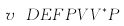<formula> <loc_0><loc_0><loc_500><loc_500>v \ D E F P V V ^ { * } P</formula> 